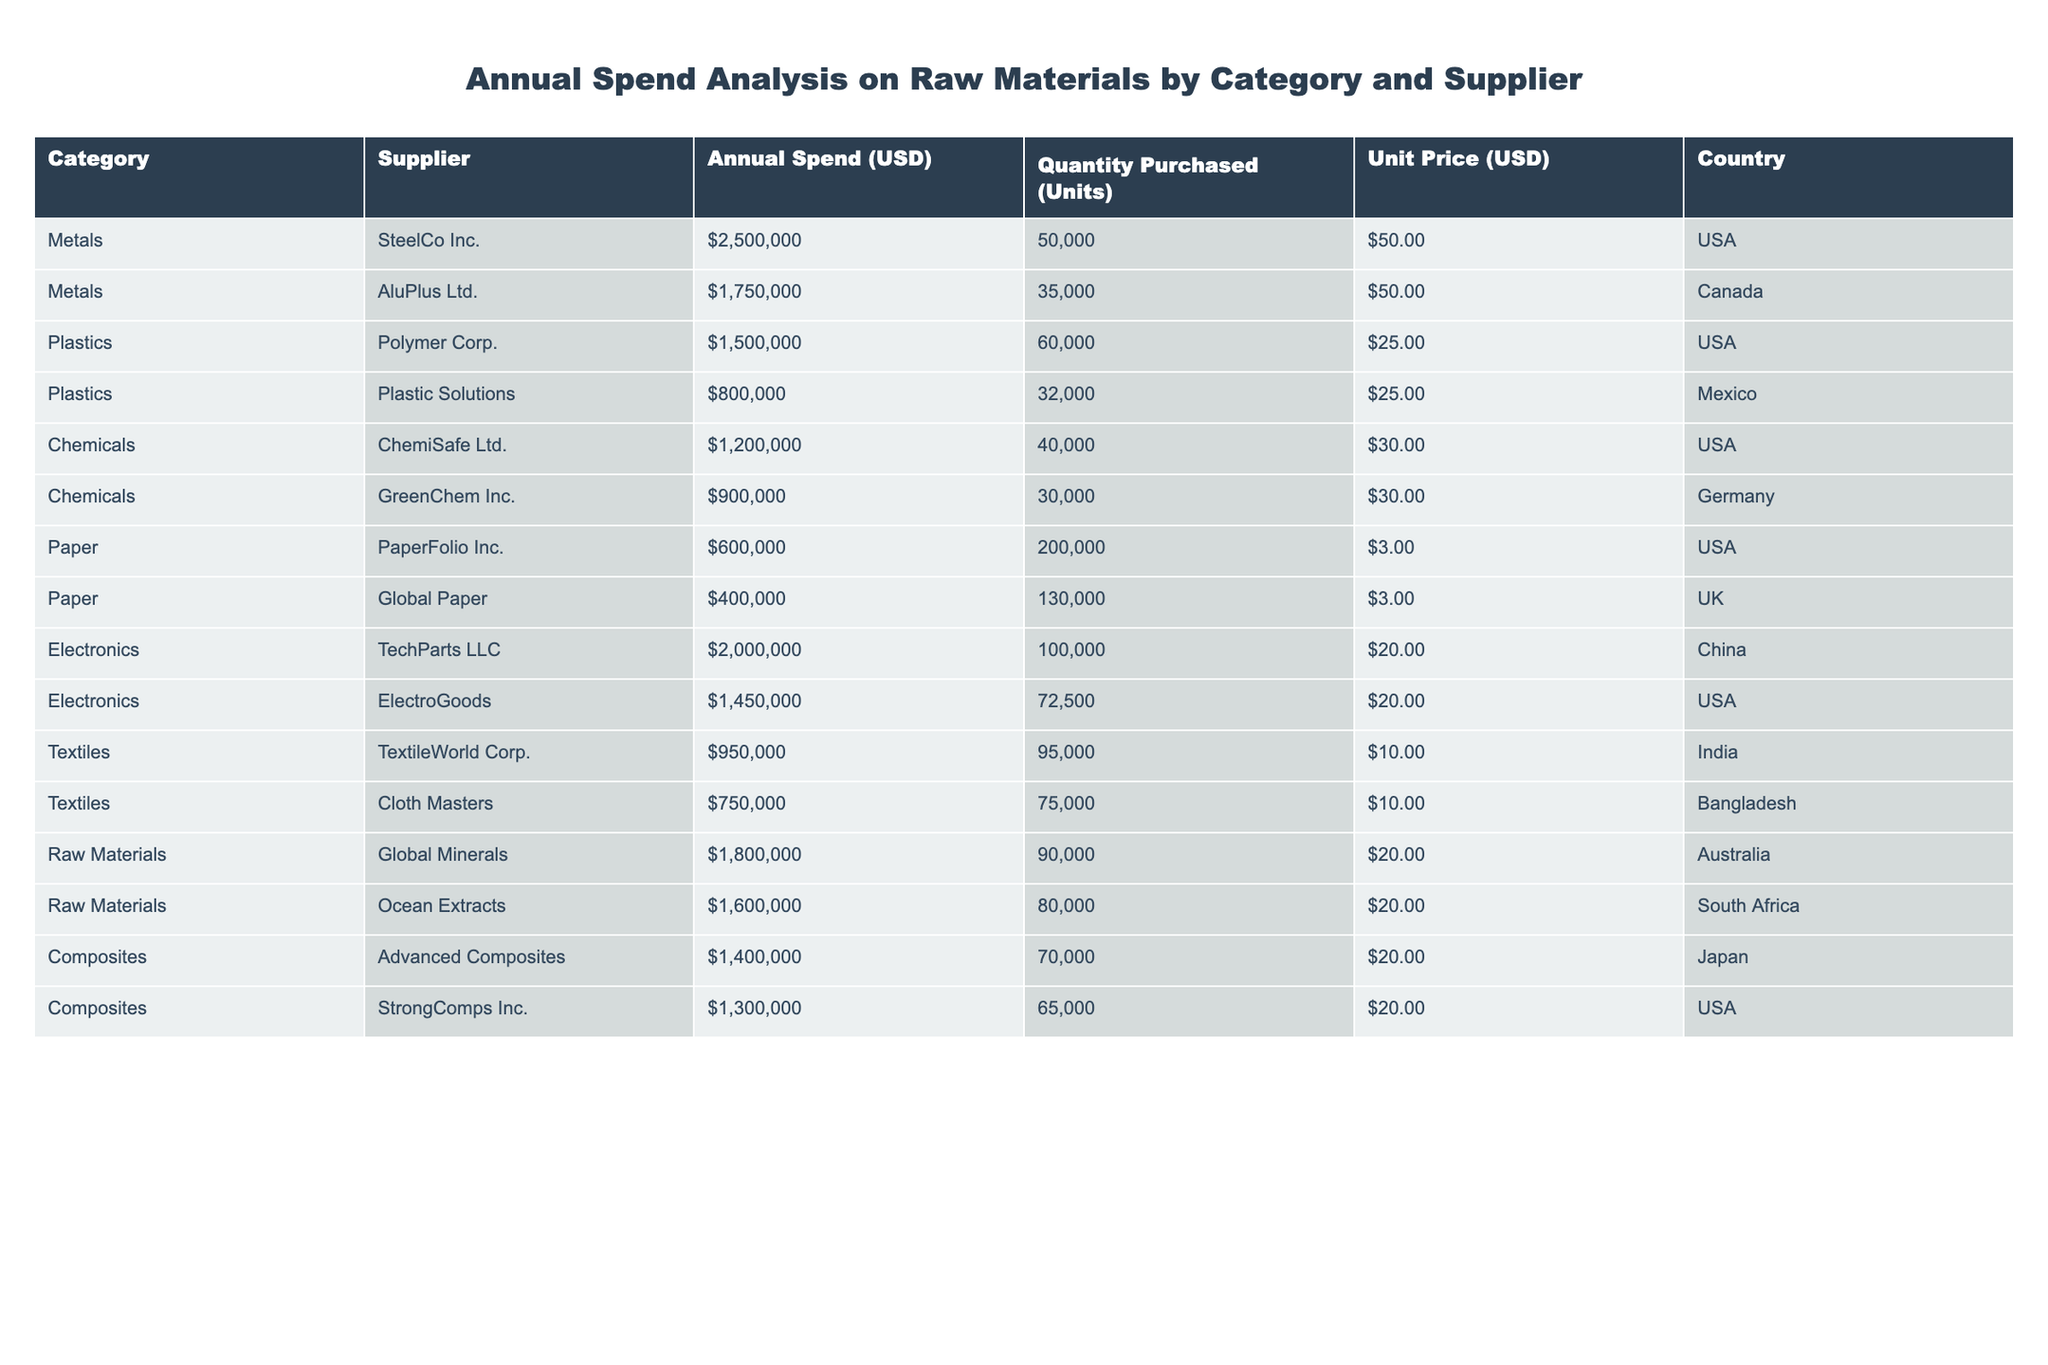What is the total annual spend for the Metals category? To find the total annual spend for the Metals category, add the annual spend for SteelCo Inc. ($2,500,000) and AluPlus Ltd. ($1,750,000). The total is $2,500,000 + $1,750,000 = $4,250,000.
Answer: $4,250,000 Which supplier has the highest unit price for Raw Materials? The unit prices for Global Minerals and Ocean Extracts are both $20. Since they are equal, both suppliers have the same highest unit price in this category.
Answer: Global Minerals and Ocean Extracts Is the annual spend for Electronics higher than for Chemicals? The total annual spend for Electronics is $3,450,000 ($2,000,000 + $1,450,000), while for Chemicals it is $2,100,000 ($1,200,000 + $900,000). Since $3,450,000 is greater than $2,100,000, the statement is true.
Answer: Yes What is the average unit price for the Plastics category? The unit prices for the Plastics category are $25 from Polymer Corp. and $25 from Plastic Solutions. To find the average, calculate (25 + 25) / 2 = 25.
Answer: $25 Which country has the supplier with the highest annual spend for Textiles? The suppliers in the Textiles category are TextileWorld Corp. (India) and Cloth Masters (Bangladesh). TextileWorld Corp. has an annual spend of $950,000, while Cloth Masters has $750,000. Thus, India has the supplier with the highest annual spend.
Answer: India What is the total quantity purchased for the Paper category? The total quantity purchased in the Paper category is the sum of all units bought from both suppliers: 200,000 (PaperFolio Inc.) + 130,000 (Global Paper) equals 330,000.
Answer: 330,000 Is it true that all suppliers in the Composites category have the same unit price? The unit prices for Advanced Composites and StrongComps Inc. are both $20, which means they are equal. Therefore, the statement is true.
Answer: Yes How much more is spent on Raw Materials compared to Textiles? Total annual spend for Raw Materials is $3,800,000 ($1,800,000 from Global Minerals + $1,600,000 from Ocean Extracts), and for Textiles it's $1,700,000 ($950,000 + $750,000). The difference is $3,800,000 - $1,700,000 = $2,100,000.
Answer: $2,100,000 What percentage of the total annual spend does Plastic Solutions account for in the Plastics category? Annual spend for Plastic Solutions is $800,000 and the total for Plastics is $2,300,000 ($1,500,000 + $800,000). Therefore, the percentage is ($800,000 / $2,300,000) * 100 = 34.78%.
Answer: 34.78% Which category has the lowest annual spend and what is the amount? By reviewing the annual spend amounts, Paper has the lowest spend totaling $1,000,000 ($600,000 + $400,000).
Answer: Paper, $1,000,000 